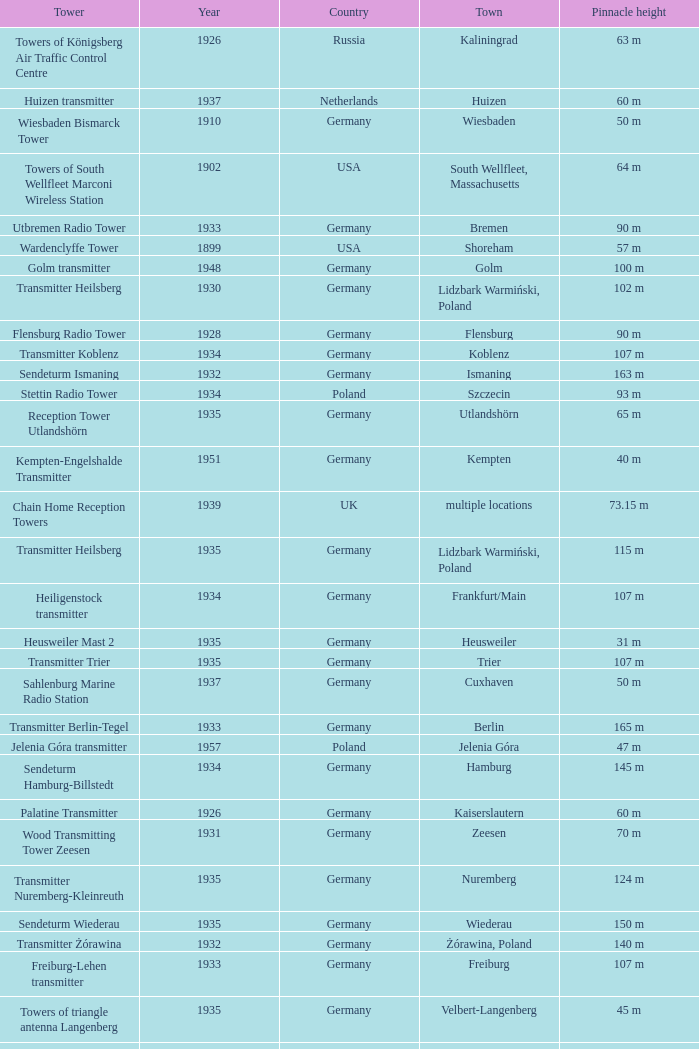Which country had a tower destroyed in 1899? USA. 